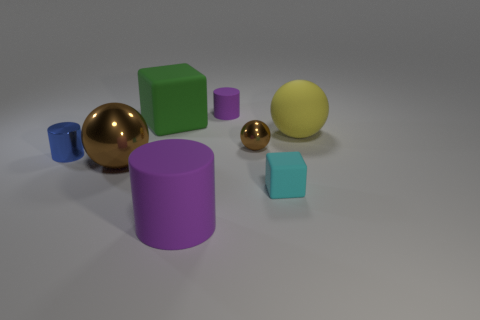There is a purple cylinder behind the sphere that is behind the small metal sphere; are there any green matte objects on the right side of it?
Ensure brevity in your answer.  No. There is a green cube; what number of cylinders are behind it?
Ensure brevity in your answer.  1. There is a large object that is the same color as the tiny sphere; what material is it?
Provide a succinct answer. Metal. How many tiny things are blue objects or red metal balls?
Make the answer very short. 1. There is a tiny matte object in front of the blue thing; what shape is it?
Ensure brevity in your answer.  Cube. Are there any other tiny matte blocks of the same color as the small matte block?
Offer a terse response. No. There is a matte cube that is behind the large brown metal sphere; is it the same size as the purple rubber object behind the shiny cylinder?
Provide a short and direct response. No. Is the number of small brown shiny objects in front of the small blue cylinder greater than the number of blue metal things that are right of the big yellow object?
Your answer should be very brief. No. Is there a tiny thing that has the same material as the large yellow thing?
Offer a terse response. Yes. Do the big cube and the big metal thing have the same color?
Your answer should be compact. No. 